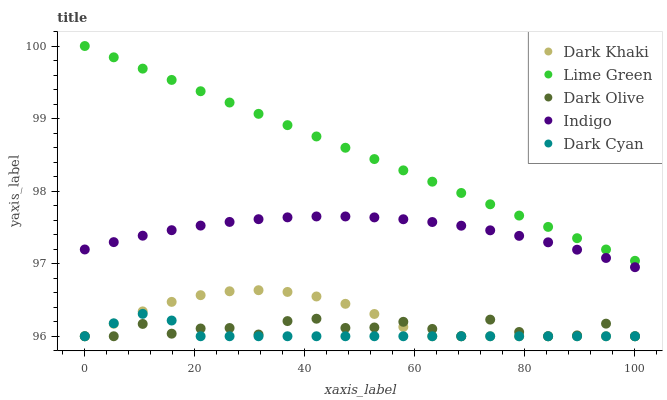Does Dark Cyan have the minimum area under the curve?
Answer yes or no. Yes. Does Lime Green have the maximum area under the curve?
Answer yes or no. Yes. Does Indigo have the minimum area under the curve?
Answer yes or no. No. Does Indigo have the maximum area under the curve?
Answer yes or no. No. Is Lime Green the smoothest?
Answer yes or no. Yes. Is Dark Olive the roughest?
Answer yes or no. Yes. Is Indigo the smoothest?
Answer yes or no. No. Is Indigo the roughest?
Answer yes or no. No. Does Dark Khaki have the lowest value?
Answer yes or no. Yes. Does Indigo have the lowest value?
Answer yes or no. No. Does Lime Green have the highest value?
Answer yes or no. Yes. Does Indigo have the highest value?
Answer yes or no. No. Is Dark Khaki less than Indigo?
Answer yes or no. Yes. Is Lime Green greater than Dark Khaki?
Answer yes or no. Yes. Does Dark Olive intersect Dark Khaki?
Answer yes or no. Yes. Is Dark Olive less than Dark Khaki?
Answer yes or no. No. Is Dark Olive greater than Dark Khaki?
Answer yes or no. No. Does Dark Khaki intersect Indigo?
Answer yes or no. No. 